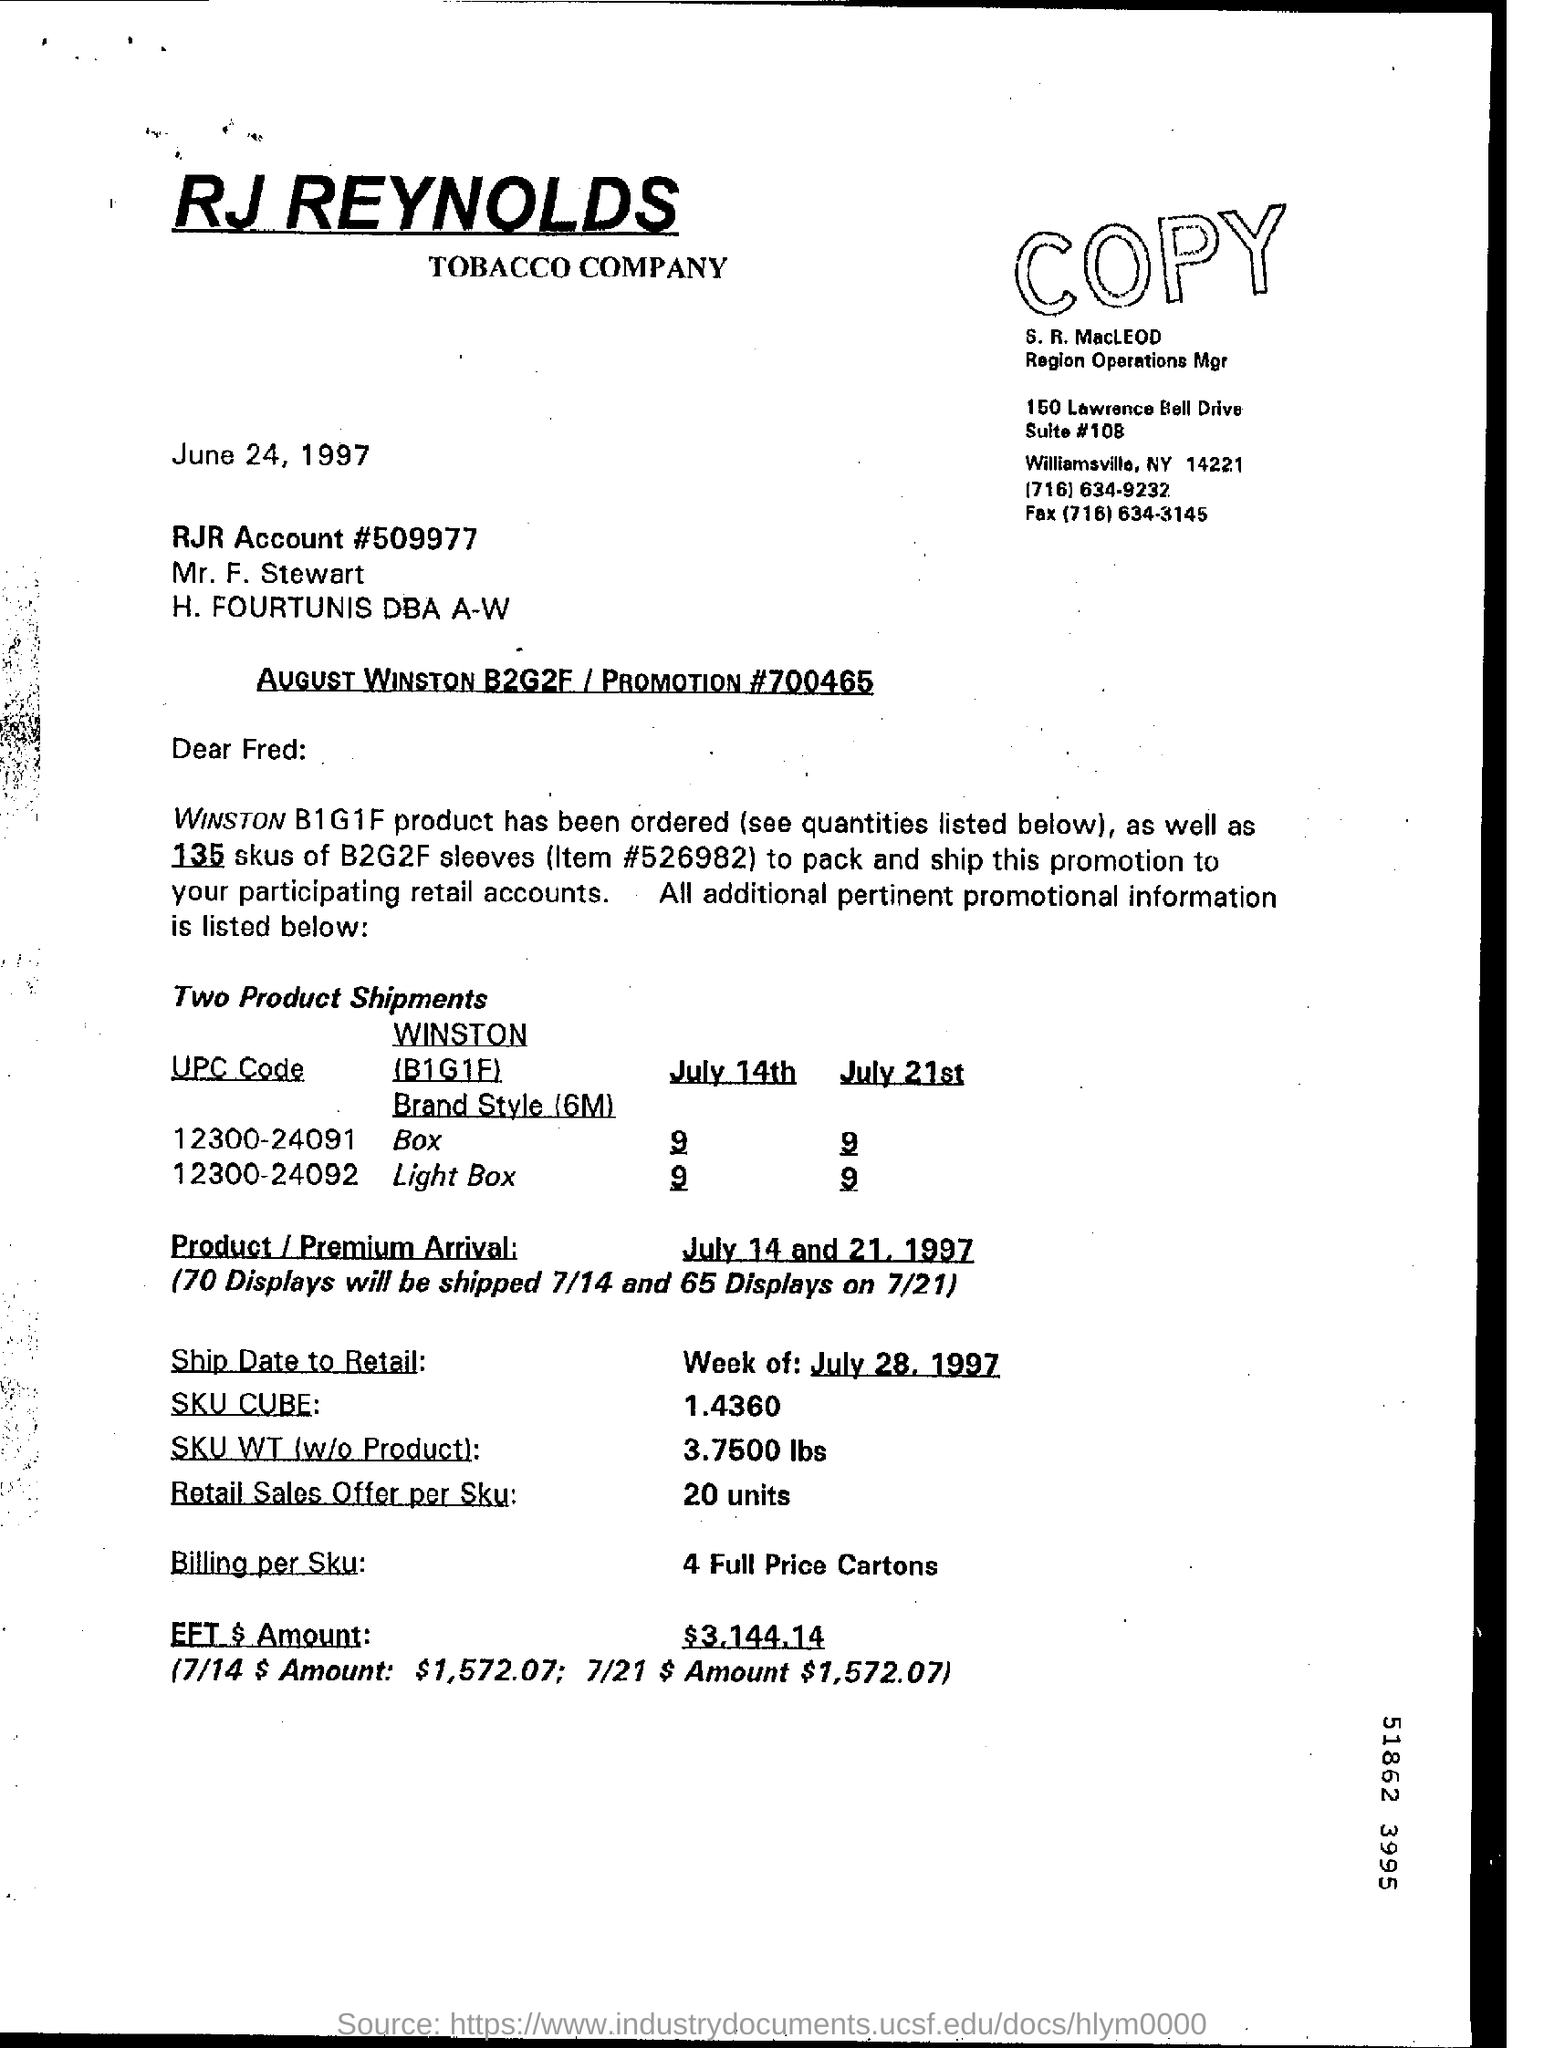Draw attention to some important aspects in this diagram. The billing for each SKU is 4 full price cartons. The letter is dated June 24, 1997. The letter is addressed to Fred. On July 14th, it is expected that 70 displays will be shipped. The SKU weight, without the product, is 3.7500 lbs. 